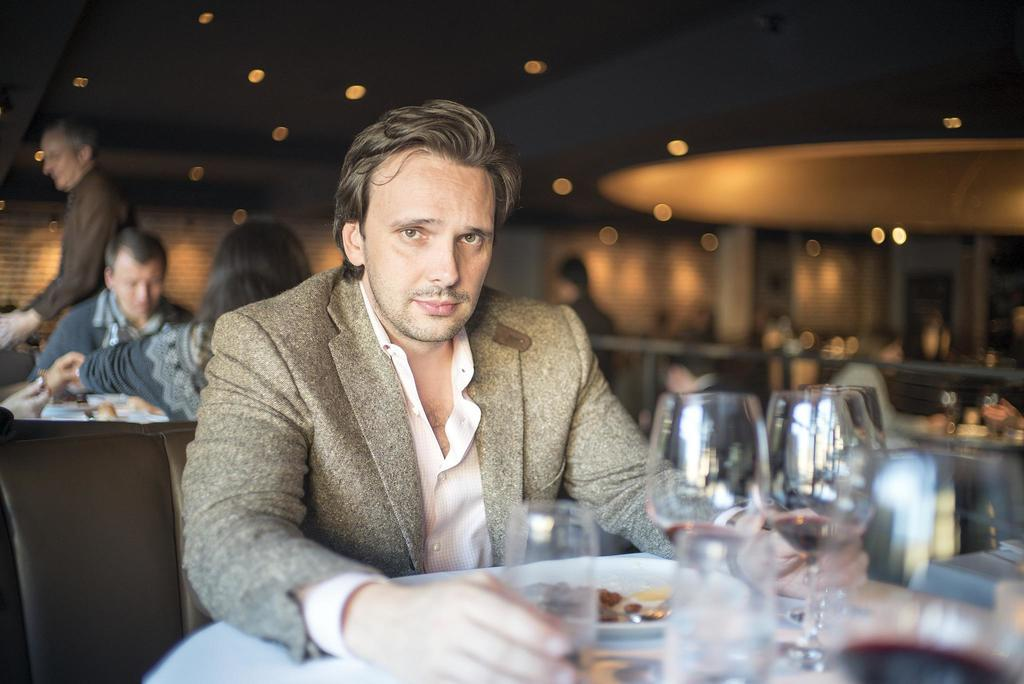What are the people in the image doing? The people in the image are sitting on chairs. What objects can be seen on the table? There are plates and wine glasses on the table. Can you describe the light arrangements in the image? There are light arrangements on the roof. How does the fan start spinning in the image? There is no fan present in the image. What is the limit of the start time for the event in the image? There is no event or time limit mentioned in the image. 